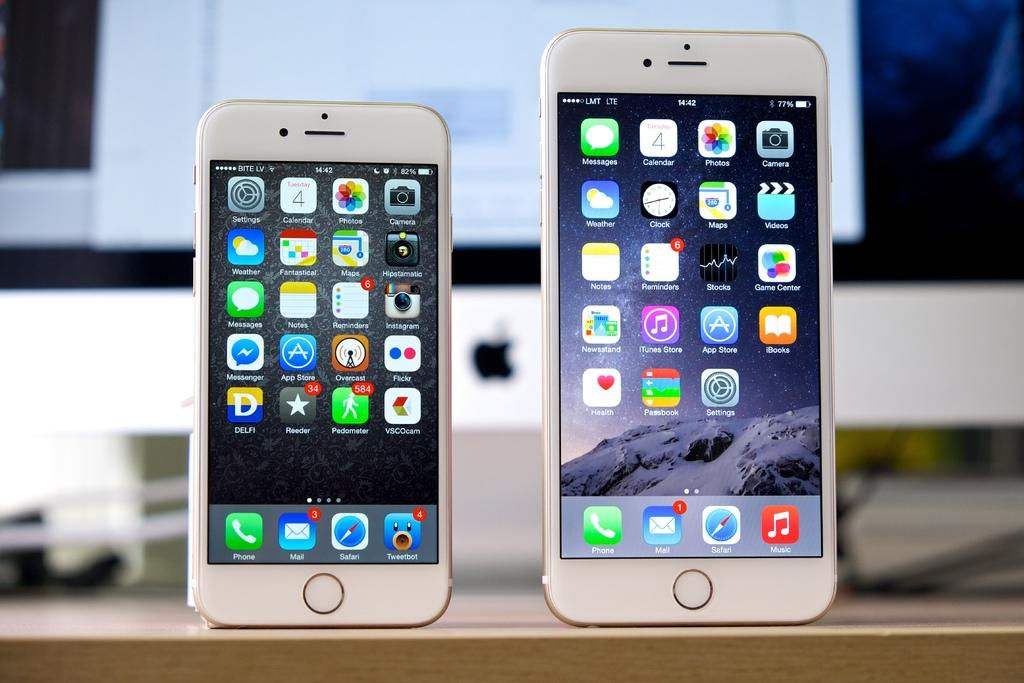<image>
Share a concise interpretation of the image provided. Two devices next to each other, the bigger one says LMT LTE in the corner. 